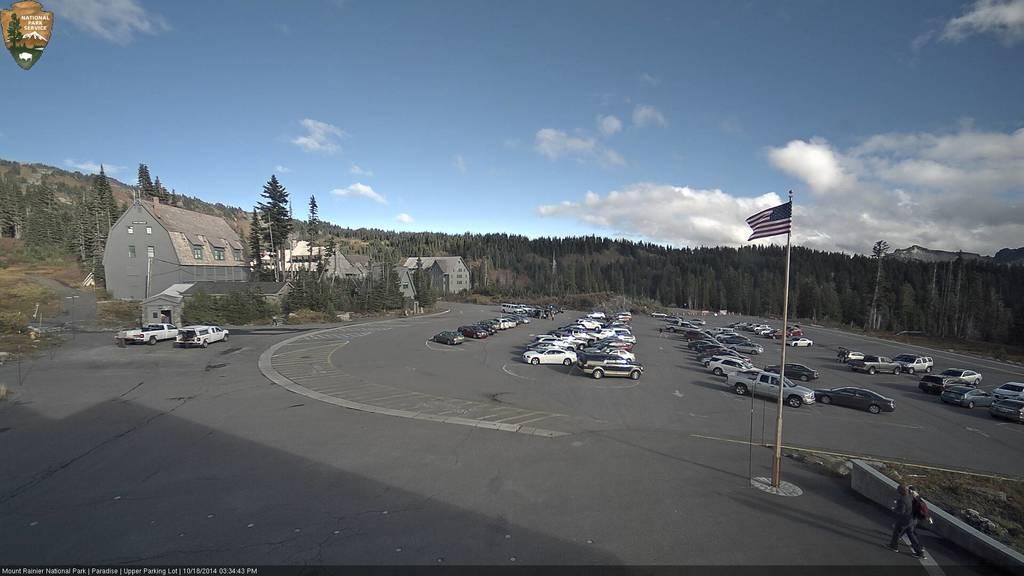How would you summarize this image in a sentence or two? In this image we can see many vehicles parked on the road. We can also see many trees in this image. There are also buildings. At the top there is sky with some clouds. At the bottom we can see the text on the border. Flag is also visible in this image. In the top left corner there is a logo. 